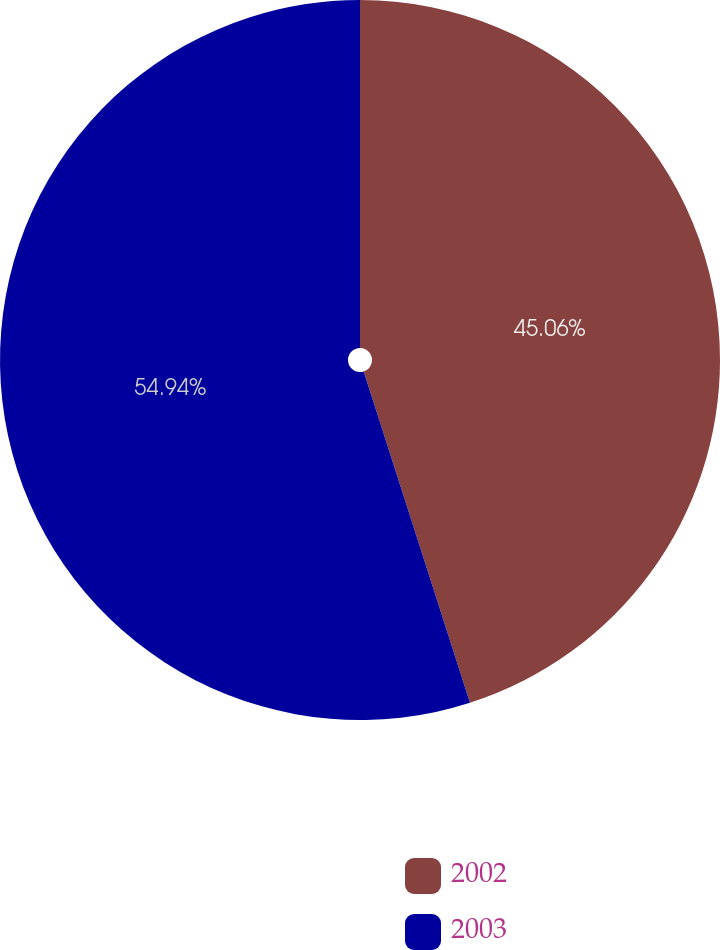Convert chart to OTSL. <chart><loc_0><loc_0><loc_500><loc_500><pie_chart><fcel>2002<fcel>2003<nl><fcel>45.06%<fcel>54.94%<nl></chart> 